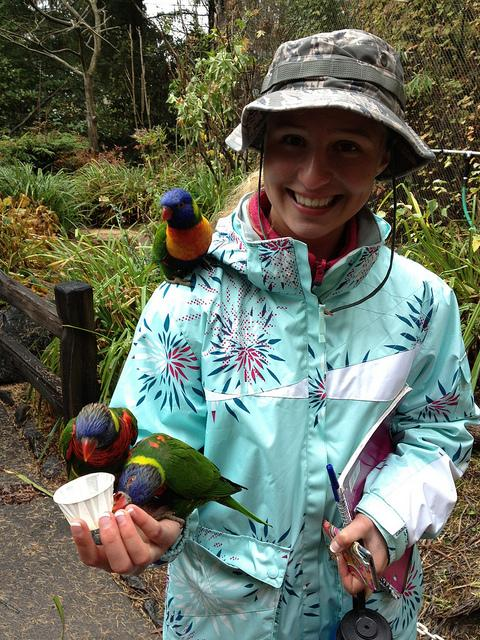What color is the rain jacket worn by the woman in the rainforest?

Choices:
A) red
B) purple
C) teal
D) orange teal 